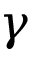<formula> <loc_0><loc_0><loc_500><loc_500>\gamma</formula> 